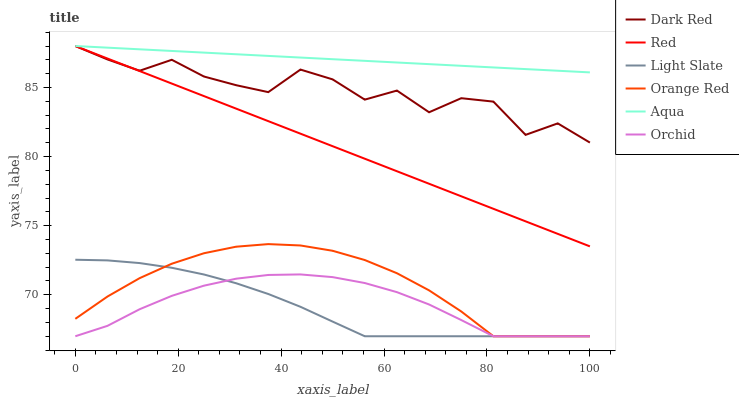Does Dark Red have the minimum area under the curve?
Answer yes or no. No. Does Dark Red have the maximum area under the curve?
Answer yes or no. No. Is Dark Red the smoothest?
Answer yes or no. No. Is Aqua the roughest?
Answer yes or no. No. Does Dark Red have the lowest value?
Answer yes or no. No. Does Orange Red have the highest value?
Answer yes or no. No. Is Orange Red less than Red?
Answer yes or no. Yes. Is Aqua greater than Orchid?
Answer yes or no. Yes. Does Orange Red intersect Red?
Answer yes or no. No. 